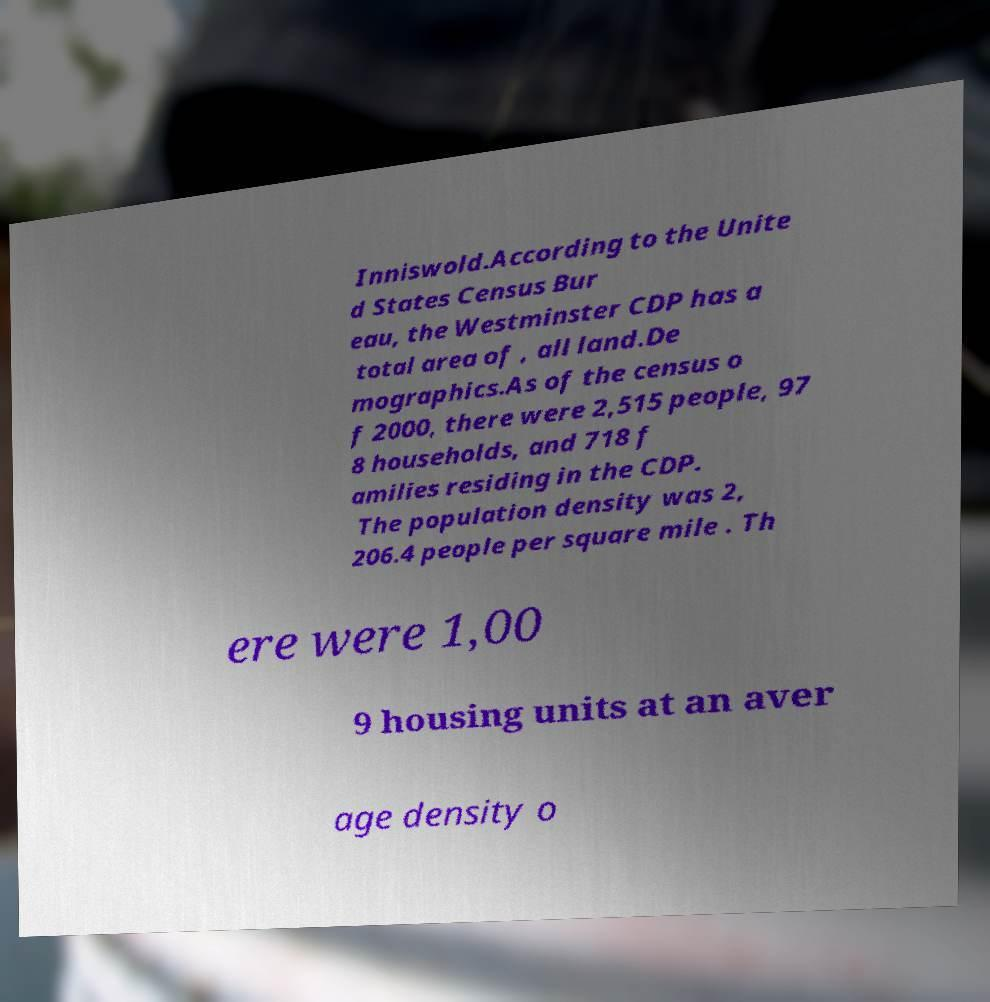Could you extract and type out the text from this image? Inniswold.According to the Unite d States Census Bur eau, the Westminster CDP has a total area of , all land.De mographics.As of the census o f 2000, there were 2,515 people, 97 8 households, and 718 f amilies residing in the CDP. The population density was 2, 206.4 people per square mile . Th ere were 1,00 9 housing units at an aver age density o 